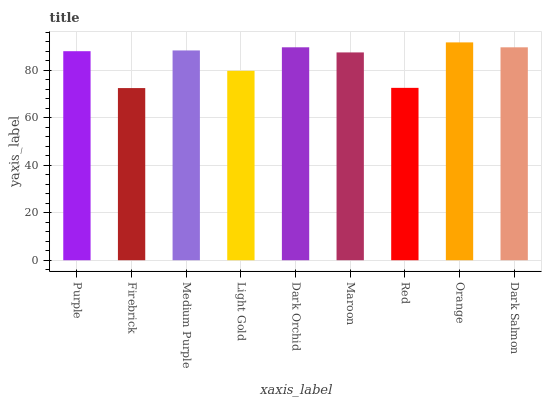Is Firebrick the minimum?
Answer yes or no. Yes. Is Orange the maximum?
Answer yes or no. Yes. Is Medium Purple the minimum?
Answer yes or no. No. Is Medium Purple the maximum?
Answer yes or no. No. Is Medium Purple greater than Firebrick?
Answer yes or no. Yes. Is Firebrick less than Medium Purple?
Answer yes or no. Yes. Is Firebrick greater than Medium Purple?
Answer yes or no. No. Is Medium Purple less than Firebrick?
Answer yes or no. No. Is Purple the high median?
Answer yes or no. Yes. Is Purple the low median?
Answer yes or no. Yes. Is Maroon the high median?
Answer yes or no. No. Is Firebrick the low median?
Answer yes or no. No. 